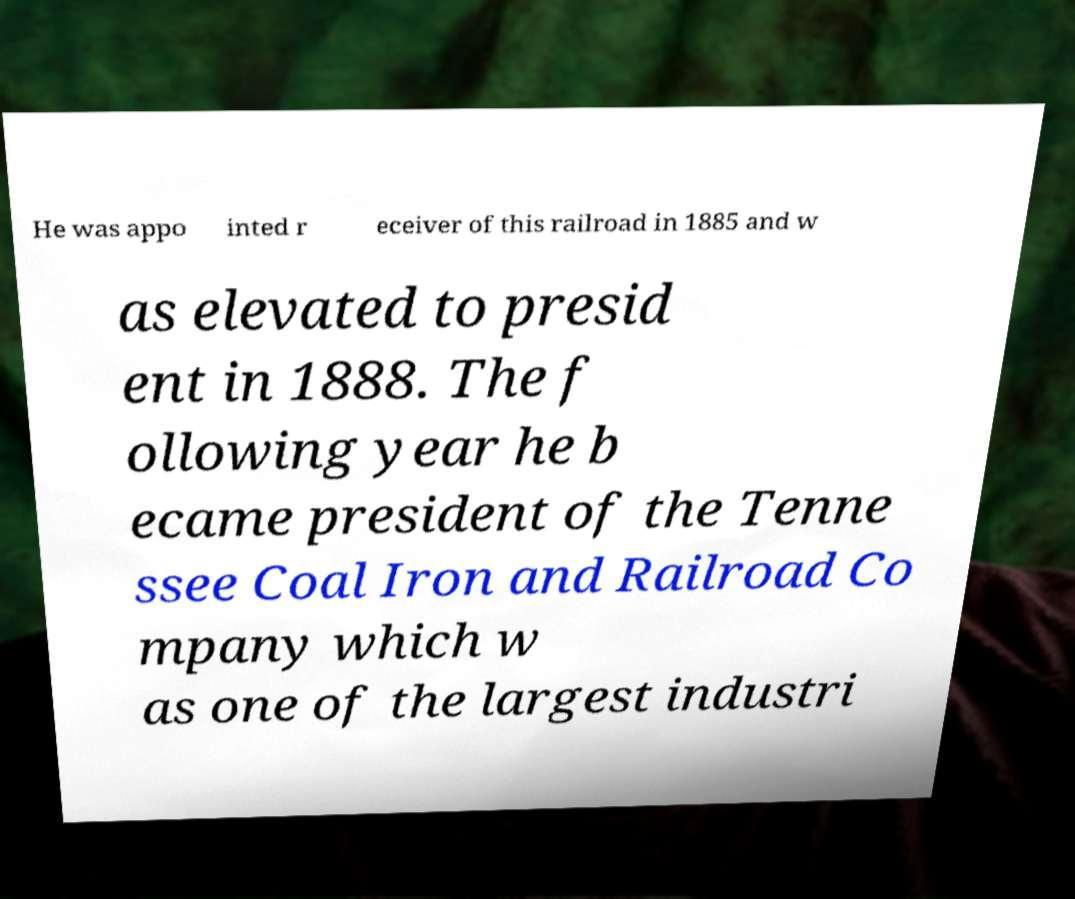What messages or text are displayed in this image? I need them in a readable, typed format. He was appo inted r eceiver of this railroad in 1885 and w as elevated to presid ent in 1888. The f ollowing year he b ecame president of the Tenne ssee Coal Iron and Railroad Co mpany which w as one of the largest industri 